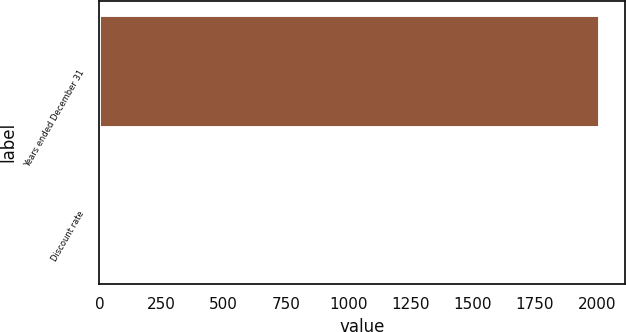Convert chart. <chart><loc_0><loc_0><loc_500><loc_500><bar_chart><fcel>Years ended December 31<fcel>Discount rate<nl><fcel>2011<fcel>5.5<nl></chart> 